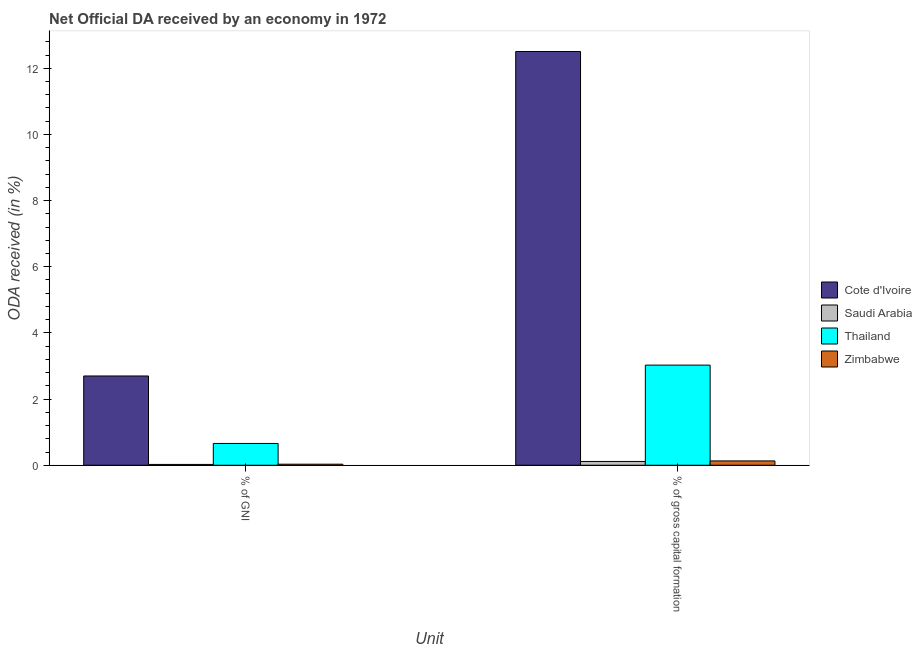How many bars are there on the 1st tick from the left?
Your response must be concise. 4. How many bars are there on the 1st tick from the right?
Your answer should be compact. 4. What is the label of the 2nd group of bars from the left?
Make the answer very short. % of gross capital formation. What is the oda received as percentage of gni in Cote d'Ivoire?
Provide a succinct answer. 2.7. Across all countries, what is the maximum oda received as percentage of gross capital formation?
Keep it short and to the point. 12.51. Across all countries, what is the minimum oda received as percentage of gni?
Provide a short and direct response. 0.02. In which country was the oda received as percentage of gni maximum?
Give a very brief answer. Cote d'Ivoire. In which country was the oda received as percentage of gni minimum?
Offer a terse response. Saudi Arabia. What is the total oda received as percentage of gni in the graph?
Keep it short and to the point. 3.41. What is the difference between the oda received as percentage of gross capital formation in Cote d'Ivoire and that in Saudi Arabia?
Your answer should be compact. 12.39. What is the difference between the oda received as percentage of gni in Saudi Arabia and the oda received as percentage of gross capital formation in Zimbabwe?
Provide a short and direct response. -0.11. What is the average oda received as percentage of gross capital formation per country?
Provide a succinct answer. 3.94. What is the difference between the oda received as percentage of gross capital formation and oda received as percentage of gni in Zimbabwe?
Your answer should be very brief. 0.1. In how many countries, is the oda received as percentage of gross capital formation greater than 1.6 %?
Make the answer very short. 2. What is the ratio of the oda received as percentage of gni in Saudi Arabia to that in Cote d'Ivoire?
Make the answer very short. 0.01. Is the oda received as percentage of gni in Saudi Arabia less than that in Zimbabwe?
Offer a very short reply. Yes. What does the 3rd bar from the left in % of GNI represents?
Ensure brevity in your answer.  Thailand. What does the 1st bar from the right in % of GNI represents?
Ensure brevity in your answer.  Zimbabwe. Are all the bars in the graph horizontal?
Offer a terse response. No. What is the difference between two consecutive major ticks on the Y-axis?
Make the answer very short. 2. Does the graph contain grids?
Offer a terse response. No. Where does the legend appear in the graph?
Make the answer very short. Center right. What is the title of the graph?
Make the answer very short. Net Official DA received by an economy in 1972. What is the label or title of the X-axis?
Provide a short and direct response. Unit. What is the label or title of the Y-axis?
Ensure brevity in your answer.  ODA received (in %). What is the ODA received (in %) in Cote d'Ivoire in % of GNI?
Offer a very short reply. 2.7. What is the ODA received (in %) in Saudi Arabia in % of GNI?
Make the answer very short. 0.02. What is the ODA received (in %) in Thailand in % of GNI?
Give a very brief answer. 0.66. What is the ODA received (in %) of Zimbabwe in % of GNI?
Your answer should be compact. 0.03. What is the ODA received (in %) of Cote d'Ivoire in % of gross capital formation?
Your answer should be very brief. 12.51. What is the ODA received (in %) of Saudi Arabia in % of gross capital formation?
Provide a short and direct response. 0.11. What is the ODA received (in %) of Thailand in % of gross capital formation?
Offer a very short reply. 3.03. What is the ODA received (in %) in Zimbabwe in % of gross capital formation?
Provide a short and direct response. 0.13. Across all Unit, what is the maximum ODA received (in %) in Cote d'Ivoire?
Your response must be concise. 12.51. Across all Unit, what is the maximum ODA received (in %) of Saudi Arabia?
Provide a succinct answer. 0.11. Across all Unit, what is the maximum ODA received (in %) of Thailand?
Keep it short and to the point. 3.03. Across all Unit, what is the maximum ODA received (in %) of Zimbabwe?
Your response must be concise. 0.13. Across all Unit, what is the minimum ODA received (in %) of Cote d'Ivoire?
Offer a terse response. 2.7. Across all Unit, what is the minimum ODA received (in %) of Saudi Arabia?
Offer a very short reply. 0.02. Across all Unit, what is the minimum ODA received (in %) of Thailand?
Your response must be concise. 0.66. Across all Unit, what is the minimum ODA received (in %) of Zimbabwe?
Make the answer very short. 0.03. What is the total ODA received (in %) of Cote d'Ivoire in the graph?
Your response must be concise. 15.2. What is the total ODA received (in %) of Saudi Arabia in the graph?
Your answer should be compact. 0.14. What is the total ODA received (in %) in Thailand in the graph?
Offer a very short reply. 3.68. What is the total ODA received (in %) in Zimbabwe in the graph?
Give a very brief answer. 0.16. What is the difference between the ODA received (in %) of Cote d'Ivoire in % of GNI and that in % of gross capital formation?
Ensure brevity in your answer.  -9.81. What is the difference between the ODA received (in %) in Saudi Arabia in % of GNI and that in % of gross capital formation?
Ensure brevity in your answer.  -0.09. What is the difference between the ODA received (in %) in Thailand in % of GNI and that in % of gross capital formation?
Give a very brief answer. -2.37. What is the difference between the ODA received (in %) in Zimbabwe in % of GNI and that in % of gross capital formation?
Your answer should be very brief. -0.1. What is the difference between the ODA received (in %) of Cote d'Ivoire in % of GNI and the ODA received (in %) of Saudi Arabia in % of gross capital formation?
Give a very brief answer. 2.58. What is the difference between the ODA received (in %) in Cote d'Ivoire in % of GNI and the ODA received (in %) in Thailand in % of gross capital formation?
Your answer should be very brief. -0.33. What is the difference between the ODA received (in %) of Cote d'Ivoire in % of GNI and the ODA received (in %) of Zimbabwe in % of gross capital formation?
Your answer should be compact. 2.57. What is the difference between the ODA received (in %) of Saudi Arabia in % of GNI and the ODA received (in %) of Thailand in % of gross capital formation?
Offer a very short reply. -3. What is the difference between the ODA received (in %) in Saudi Arabia in % of GNI and the ODA received (in %) in Zimbabwe in % of gross capital formation?
Give a very brief answer. -0.11. What is the difference between the ODA received (in %) of Thailand in % of GNI and the ODA received (in %) of Zimbabwe in % of gross capital formation?
Offer a terse response. 0.53. What is the average ODA received (in %) of Cote d'Ivoire per Unit?
Keep it short and to the point. 7.6. What is the average ODA received (in %) in Saudi Arabia per Unit?
Make the answer very short. 0.07. What is the average ODA received (in %) of Thailand per Unit?
Your response must be concise. 1.84. What is the average ODA received (in %) in Zimbabwe per Unit?
Your answer should be very brief. 0.08. What is the difference between the ODA received (in %) in Cote d'Ivoire and ODA received (in %) in Saudi Arabia in % of GNI?
Ensure brevity in your answer.  2.67. What is the difference between the ODA received (in %) in Cote d'Ivoire and ODA received (in %) in Thailand in % of GNI?
Your answer should be very brief. 2.04. What is the difference between the ODA received (in %) of Cote d'Ivoire and ODA received (in %) of Zimbabwe in % of GNI?
Keep it short and to the point. 2.67. What is the difference between the ODA received (in %) in Saudi Arabia and ODA received (in %) in Thailand in % of GNI?
Keep it short and to the point. -0.63. What is the difference between the ODA received (in %) in Saudi Arabia and ODA received (in %) in Zimbabwe in % of GNI?
Provide a succinct answer. -0.01. What is the difference between the ODA received (in %) in Thailand and ODA received (in %) in Zimbabwe in % of GNI?
Ensure brevity in your answer.  0.63. What is the difference between the ODA received (in %) in Cote d'Ivoire and ODA received (in %) in Saudi Arabia in % of gross capital formation?
Your answer should be very brief. 12.39. What is the difference between the ODA received (in %) of Cote d'Ivoire and ODA received (in %) of Thailand in % of gross capital formation?
Give a very brief answer. 9.48. What is the difference between the ODA received (in %) in Cote d'Ivoire and ODA received (in %) in Zimbabwe in % of gross capital formation?
Provide a succinct answer. 12.37. What is the difference between the ODA received (in %) of Saudi Arabia and ODA received (in %) of Thailand in % of gross capital formation?
Provide a short and direct response. -2.91. What is the difference between the ODA received (in %) of Saudi Arabia and ODA received (in %) of Zimbabwe in % of gross capital formation?
Offer a terse response. -0.02. What is the difference between the ODA received (in %) in Thailand and ODA received (in %) in Zimbabwe in % of gross capital formation?
Make the answer very short. 2.9. What is the ratio of the ODA received (in %) in Cote d'Ivoire in % of GNI to that in % of gross capital formation?
Your response must be concise. 0.22. What is the ratio of the ODA received (in %) in Saudi Arabia in % of GNI to that in % of gross capital formation?
Ensure brevity in your answer.  0.21. What is the ratio of the ODA received (in %) in Thailand in % of GNI to that in % of gross capital formation?
Offer a terse response. 0.22. What is the ratio of the ODA received (in %) in Zimbabwe in % of GNI to that in % of gross capital formation?
Your answer should be compact. 0.24. What is the difference between the highest and the second highest ODA received (in %) in Cote d'Ivoire?
Your answer should be compact. 9.81. What is the difference between the highest and the second highest ODA received (in %) in Saudi Arabia?
Keep it short and to the point. 0.09. What is the difference between the highest and the second highest ODA received (in %) of Thailand?
Keep it short and to the point. 2.37. What is the difference between the highest and the second highest ODA received (in %) in Zimbabwe?
Provide a short and direct response. 0.1. What is the difference between the highest and the lowest ODA received (in %) in Cote d'Ivoire?
Offer a very short reply. 9.81. What is the difference between the highest and the lowest ODA received (in %) in Saudi Arabia?
Ensure brevity in your answer.  0.09. What is the difference between the highest and the lowest ODA received (in %) of Thailand?
Your response must be concise. 2.37. What is the difference between the highest and the lowest ODA received (in %) of Zimbabwe?
Offer a terse response. 0.1. 